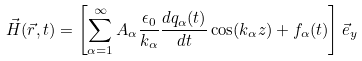<formula> <loc_0><loc_0><loc_500><loc_500>\vec { H } ( \vec { r } , t ) = \left [ \sum _ { \alpha = 1 } ^ { \infty } A _ { \alpha } \frac { \epsilon _ { 0 } } { k _ { \alpha } } \frac { d q _ { \alpha } ( t ) } { d t } \cos ( k _ { \alpha } z ) + f _ { \alpha } ( t ) \right ] \vec { e } _ { y }</formula> 